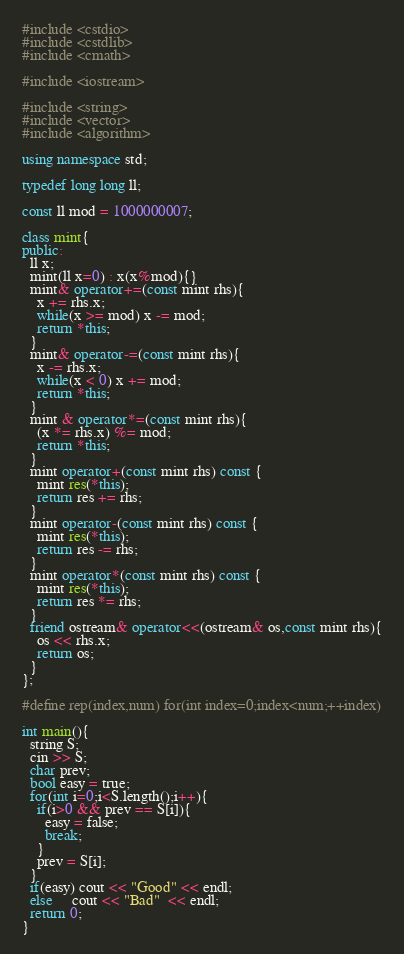Convert code to text. <code><loc_0><loc_0><loc_500><loc_500><_C++_>#include <cstdio>
#include <cstdlib>
#include <cmath>

#include <iostream>

#include <string>
#include <vector>
#include <algorithm>

using namespace std;

typedef long long ll;

const ll mod = 1000000007;

class mint{
public:
  ll x;
  mint(ll x=0) : x(x%mod){}
  mint& operator+=(const mint rhs){
    x += rhs.x;
    while(x >= mod) x -= mod;
    return *this;
  }
  mint& operator-=(const mint rhs){
    x -= rhs.x;
    while(x < 0) x += mod;
    return *this;
  }
  mint & operator*=(const mint rhs){
    (x *= rhs.x) %= mod;
    return *this;
  }
  mint operator+(const mint rhs) const {
    mint res(*this);
    return res += rhs;
  }
  mint operator-(const mint rhs) const {
    mint res(*this);
    return res -= rhs;
  }
  mint operator*(const mint rhs) const {
    mint res(*this);
    return res *= rhs;
  }
  friend ostream& operator<<(ostream& os,const mint rhs){
    os << rhs.x;
    return os;
  }
};

#define rep(index,num) for(int index=0;index<num;++index)

int main(){
  string S;
  cin >> S;
  char prev;
  bool easy = true;
  for(int i=0;i<S.length();i++){
    if(i>0 && prev == S[i]){
      easy = false;
      break;
    }
    prev = S[i];
  }
  if(easy) cout << "Good" << endl;
  else     cout << "Bad"  << endl;
  return 0;
}
</code> 